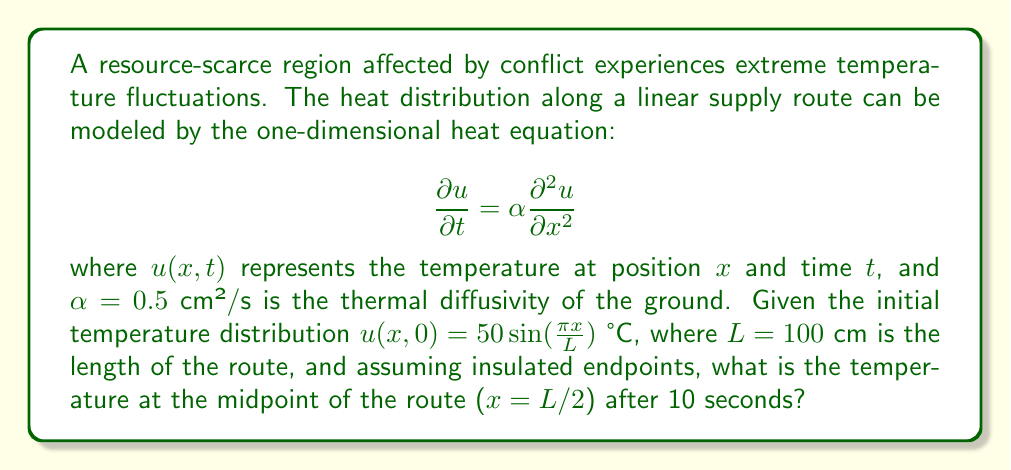What is the answer to this math problem? To solve this problem, we need to use the separation of variables method for the heat equation with the given initial and boundary conditions.

Step 1: The general solution for the heat equation with insulated endpoints is:

$$u(x,t) = \sum_{n=1}^{\infty} B_n \sin(\frac{n\pi x}{L}) e^{-\alpha (\frac{n\pi}{L})^2 t}$$

Step 2: The initial condition is given as $u(x,0) = 50 \sin(\frac{\pi x}{L})$. Comparing this with the general solution at $t=0$, we can see that only the first term ($n=1$) of the series is non-zero, with $B_1 = 50$.

Step 3: Therefore, our specific solution is:

$$u(x,t) = 50 \sin(\frac{\pi x}{L}) e^{-\alpha (\frac{\pi}{L})^2 t}$$

Step 4: We need to find $u(L/2, 10)$. Substituting the given values:

$$u(50, 10) = 50 \sin(\frac{\pi \cdot 50}{100}) e^{-0.5 (\frac{\pi}{100})^2 \cdot 10}$$

Step 5: Simplify:
$$u(50, 10) = 50 \sin(\frac{\pi}{2}) e^{-0.5 (\frac{\pi}{100})^2 \cdot 10}$$

$$u(50, 10) = 50 \cdot 1 \cdot e^{-0.5 (\frac{\pi^2}{10000}) \cdot 10}$$

$$u(50, 10) = 50 e^{-\frac{\pi^2}{2000}}$$

Step 6: Calculate the final value:
$$u(50, 10) \approx 44.93 \text{ °C}$$
Answer: 44.93 °C 